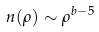Convert formula to latex. <formula><loc_0><loc_0><loc_500><loc_500>n ( \rho ) \sim \rho ^ { b - 5 }</formula> 